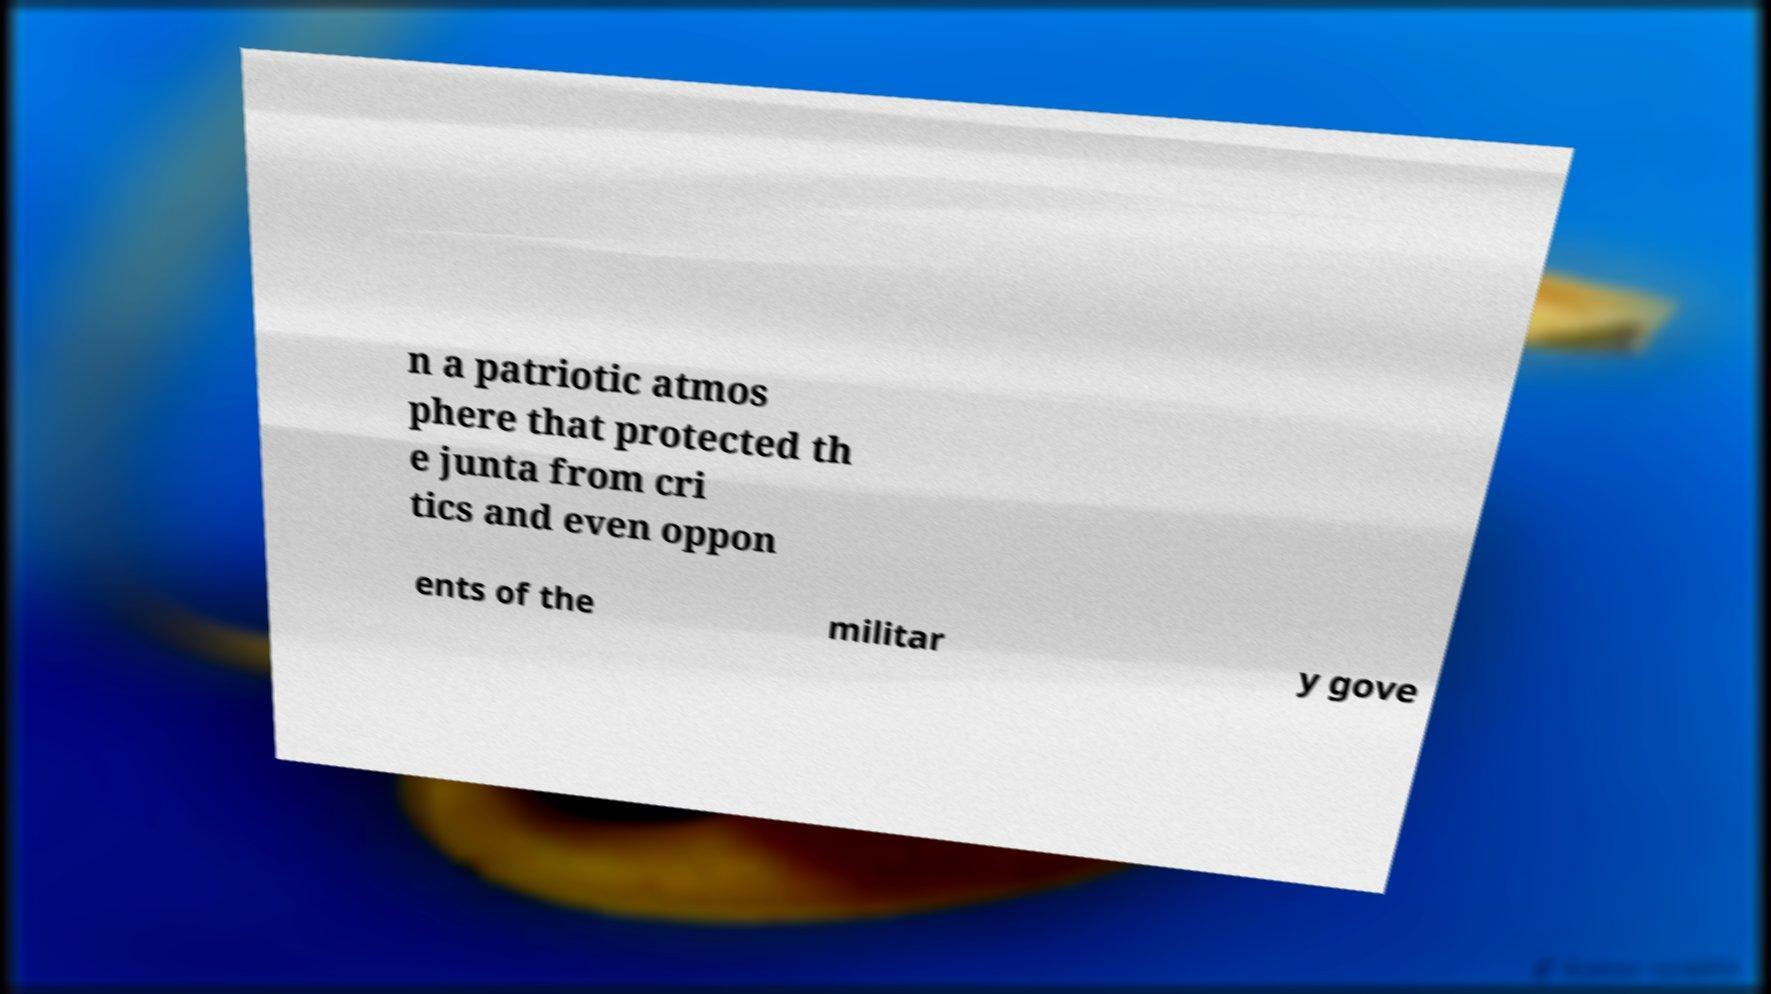What messages or text are displayed in this image? I need them in a readable, typed format. n a patriotic atmos phere that protected th e junta from cri tics and even oppon ents of the militar y gove 